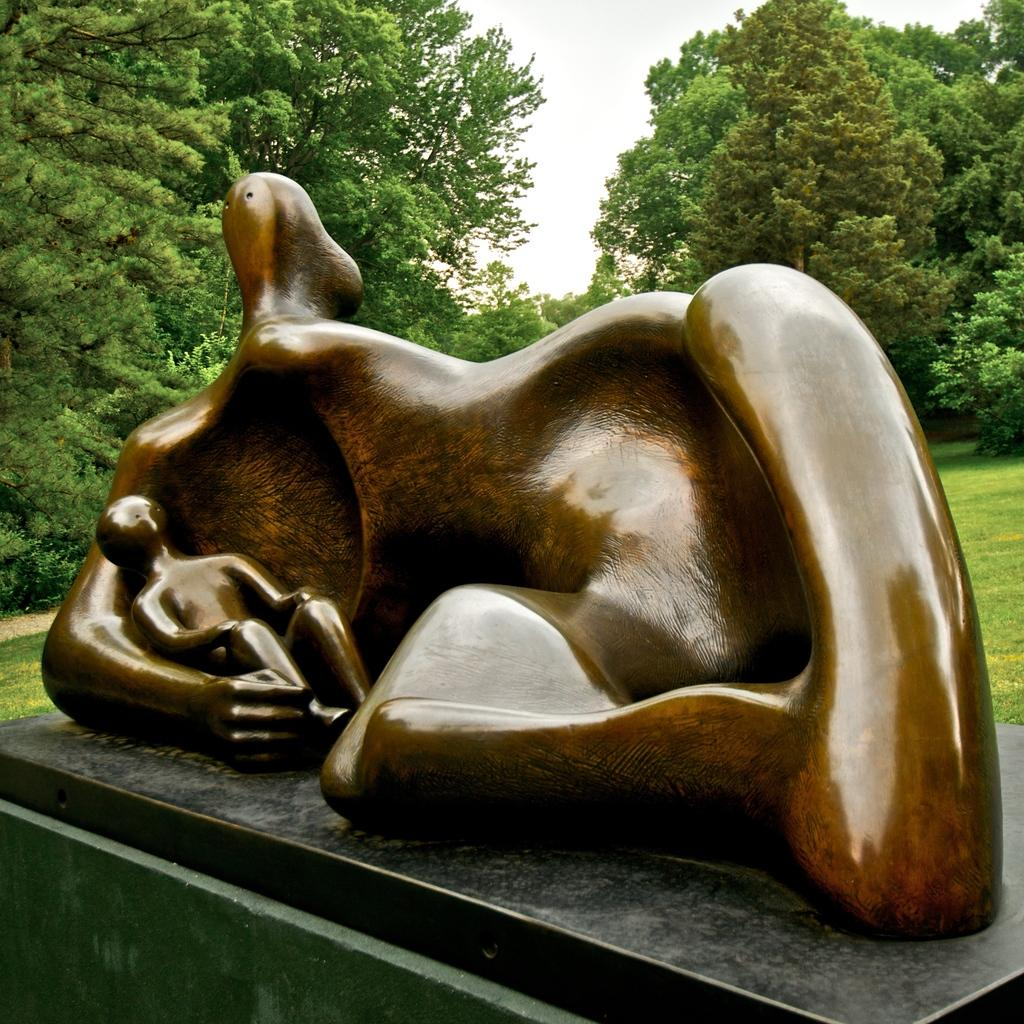What is the main subject in the image? There is a statue in the image. What type of vegetation can be seen in the image? There is grass and trees in the image. What is visible in the background of the image? The sky is visible in the background of the image. What type of fang can be seen on the statue in the image? There is no fang present on the statue in the image. What thing is being viewed in the image? The image itself is being viewed, but there is no specific "thing" being viewed within the image. 